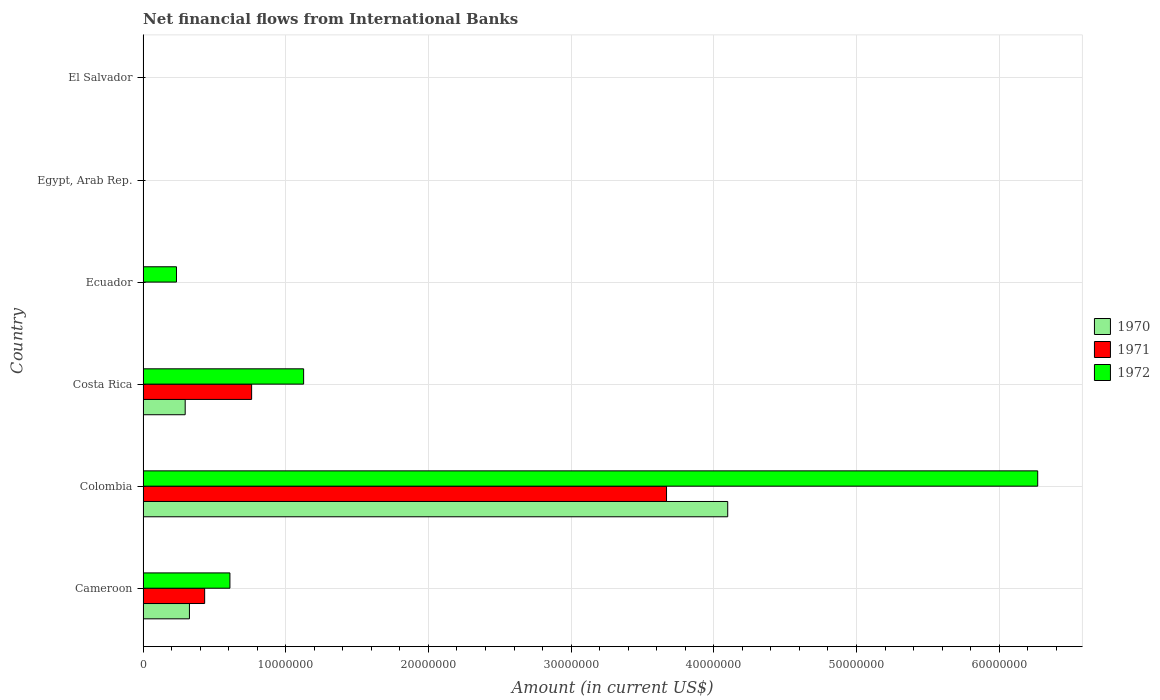Are the number of bars per tick equal to the number of legend labels?
Make the answer very short. No. Are the number of bars on each tick of the Y-axis equal?
Provide a short and direct response. No. What is the label of the 6th group of bars from the top?
Your response must be concise. Cameroon. In how many cases, is the number of bars for a given country not equal to the number of legend labels?
Your answer should be compact. 3. Across all countries, what is the maximum net financial aid flows in 1972?
Your response must be concise. 6.27e+07. Across all countries, what is the minimum net financial aid flows in 1972?
Ensure brevity in your answer.  0. In which country was the net financial aid flows in 1971 maximum?
Your response must be concise. Colombia. What is the total net financial aid flows in 1972 in the graph?
Give a very brief answer. 8.24e+07. What is the difference between the net financial aid flows in 1972 in Cameroon and that in Colombia?
Offer a very short reply. -5.66e+07. What is the difference between the net financial aid flows in 1972 in El Salvador and the net financial aid flows in 1970 in Costa Rica?
Your answer should be very brief. -2.95e+06. What is the average net financial aid flows in 1971 per country?
Offer a very short reply. 8.10e+06. What is the difference between the net financial aid flows in 1971 and net financial aid flows in 1970 in Cameroon?
Offer a very short reply. 1.07e+06. In how many countries, is the net financial aid flows in 1971 greater than 42000000 US$?
Your response must be concise. 0. What is the ratio of the net financial aid flows in 1970 in Cameroon to that in Colombia?
Give a very brief answer. 0.08. Is the difference between the net financial aid flows in 1971 in Cameroon and Colombia greater than the difference between the net financial aid flows in 1970 in Cameroon and Colombia?
Keep it short and to the point. Yes. What is the difference between the highest and the second highest net financial aid flows in 1972?
Ensure brevity in your answer.  5.14e+07. What is the difference between the highest and the lowest net financial aid flows in 1971?
Keep it short and to the point. 3.67e+07. In how many countries, is the net financial aid flows in 1971 greater than the average net financial aid flows in 1971 taken over all countries?
Your answer should be compact. 1. Is it the case that in every country, the sum of the net financial aid flows in 1972 and net financial aid flows in 1970 is greater than the net financial aid flows in 1971?
Your response must be concise. No. Are all the bars in the graph horizontal?
Offer a terse response. Yes. What is the difference between two consecutive major ticks on the X-axis?
Offer a terse response. 1.00e+07. Are the values on the major ticks of X-axis written in scientific E-notation?
Provide a short and direct response. No. Does the graph contain any zero values?
Give a very brief answer. Yes. Where does the legend appear in the graph?
Give a very brief answer. Center right. What is the title of the graph?
Offer a very short reply. Net financial flows from International Banks. What is the label or title of the Y-axis?
Ensure brevity in your answer.  Country. What is the Amount (in current US$) of 1970 in Cameroon?
Your response must be concise. 3.25e+06. What is the Amount (in current US$) of 1971 in Cameroon?
Keep it short and to the point. 4.32e+06. What is the Amount (in current US$) in 1972 in Cameroon?
Your answer should be compact. 6.09e+06. What is the Amount (in current US$) in 1970 in Colombia?
Keep it short and to the point. 4.10e+07. What is the Amount (in current US$) in 1971 in Colombia?
Offer a terse response. 3.67e+07. What is the Amount (in current US$) in 1972 in Colombia?
Provide a short and direct response. 6.27e+07. What is the Amount (in current US$) in 1970 in Costa Rica?
Make the answer very short. 2.95e+06. What is the Amount (in current US$) of 1971 in Costa Rica?
Make the answer very short. 7.61e+06. What is the Amount (in current US$) in 1972 in Costa Rica?
Offer a terse response. 1.13e+07. What is the Amount (in current US$) in 1970 in Ecuador?
Give a very brief answer. 0. What is the Amount (in current US$) of 1971 in Ecuador?
Give a very brief answer. 0. What is the Amount (in current US$) of 1972 in Ecuador?
Provide a short and direct response. 2.34e+06. What is the Amount (in current US$) in 1970 in Egypt, Arab Rep.?
Your response must be concise. 0. What is the Amount (in current US$) in 1971 in Egypt, Arab Rep.?
Your answer should be very brief. 0. What is the Amount (in current US$) of 1970 in El Salvador?
Provide a succinct answer. 0. What is the Amount (in current US$) of 1971 in El Salvador?
Offer a terse response. 0. What is the Amount (in current US$) of 1972 in El Salvador?
Provide a succinct answer. 0. Across all countries, what is the maximum Amount (in current US$) of 1970?
Provide a succinct answer. 4.10e+07. Across all countries, what is the maximum Amount (in current US$) in 1971?
Offer a terse response. 3.67e+07. Across all countries, what is the maximum Amount (in current US$) of 1972?
Your answer should be very brief. 6.27e+07. Across all countries, what is the minimum Amount (in current US$) in 1970?
Provide a succinct answer. 0. Across all countries, what is the minimum Amount (in current US$) of 1971?
Give a very brief answer. 0. Across all countries, what is the minimum Amount (in current US$) in 1972?
Your response must be concise. 0. What is the total Amount (in current US$) in 1970 in the graph?
Make the answer very short. 4.72e+07. What is the total Amount (in current US$) in 1971 in the graph?
Give a very brief answer. 4.86e+07. What is the total Amount (in current US$) in 1972 in the graph?
Make the answer very short. 8.24e+07. What is the difference between the Amount (in current US$) of 1970 in Cameroon and that in Colombia?
Your answer should be compact. -3.77e+07. What is the difference between the Amount (in current US$) in 1971 in Cameroon and that in Colombia?
Offer a terse response. -3.24e+07. What is the difference between the Amount (in current US$) of 1972 in Cameroon and that in Colombia?
Offer a terse response. -5.66e+07. What is the difference between the Amount (in current US$) of 1970 in Cameroon and that in Costa Rica?
Make the answer very short. 2.98e+05. What is the difference between the Amount (in current US$) of 1971 in Cameroon and that in Costa Rica?
Offer a very short reply. -3.29e+06. What is the difference between the Amount (in current US$) of 1972 in Cameroon and that in Costa Rica?
Provide a short and direct response. -5.17e+06. What is the difference between the Amount (in current US$) in 1972 in Cameroon and that in Ecuador?
Provide a succinct answer. 3.74e+06. What is the difference between the Amount (in current US$) in 1970 in Colombia and that in Costa Rica?
Keep it short and to the point. 3.80e+07. What is the difference between the Amount (in current US$) of 1971 in Colombia and that in Costa Rica?
Offer a terse response. 2.91e+07. What is the difference between the Amount (in current US$) in 1972 in Colombia and that in Costa Rica?
Your answer should be very brief. 5.14e+07. What is the difference between the Amount (in current US$) in 1972 in Colombia and that in Ecuador?
Your response must be concise. 6.04e+07. What is the difference between the Amount (in current US$) in 1972 in Costa Rica and that in Ecuador?
Your answer should be very brief. 8.91e+06. What is the difference between the Amount (in current US$) in 1970 in Cameroon and the Amount (in current US$) in 1971 in Colombia?
Your answer should be very brief. -3.34e+07. What is the difference between the Amount (in current US$) in 1970 in Cameroon and the Amount (in current US$) in 1972 in Colombia?
Your response must be concise. -5.94e+07. What is the difference between the Amount (in current US$) in 1971 in Cameroon and the Amount (in current US$) in 1972 in Colombia?
Ensure brevity in your answer.  -5.84e+07. What is the difference between the Amount (in current US$) of 1970 in Cameroon and the Amount (in current US$) of 1971 in Costa Rica?
Your answer should be very brief. -4.36e+06. What is the difference between the Amount (in current US$) in 1970 in Cameroon and the Amount (in current US$) in 1972 in Costa Rica?
Ensure brevity in your answer.  -8.00e+06. What is the difference between the Amount (in current US$) in 1971 in Cameroon and the Amount (in current US$) in 1972 in Costa Rica?
Give a very brief answer. -6.94e+06. What is the difference between the Amount (in current US$) of 1970 in Cameroon and the Amount (in current US$) of 1972 in Ecuador?
Provide a succinct answer. 9.08e+05. What is the difference between the Amount (in current US$) of 1971 in Cameroon and the Amount (in current US$) of 1972 in Ecuador?
Your answer should be very brief. 1.98e+06. What is the difference between the Amount (in current US$) in 1970 in Colombia and the Amount (in current US$) in 1971 in Costa Rica?
Offer a terse response. 3.34e+07. What is the difference between the Amount (in current US$) of 1970 in Colombia and the Amount (in current US$) of 1972 in Costa Rica?
Your answer should be very brief. 2.97e+07. What is the difference between the Amount (in current US$) in 1971 in Colombia and the Amount (in current US$) in 1972 in Costa Rica?
Make the answer very short. 2.54e+07. What is the difference between the Amount (in current US$) in 1970 in Colombia and the Amount (in current US$) in 1972 in Ecuador?
Your response must be concise. 3.86e+07. What is the difference between the Amount (in current US$) of 1971 in Colombia and the Amount (in current US$) of 1972 in Ecuador?
Your response must be concise. 3.43e+07. What is the difference between the Amount (in current US$) in 1970 in Costa Rica and the Amount (in current US$) in 1972 in Ecuador?
Your answer should be very brief. 6.10e+05. What is the difference between the Amount (in current US$) of 1971 in Costa Rica and the Amount (in current US$) of 1972 in Ecuador?
Ensure brevity in your answer.  5.27e+06. What is the average Amount (in current US$) in 1970 per country?
Your answer should be very brief. 7.86e+06. What is the average Amount (in current US$) of 1971 per country?
Provide a short and direct response. 8.10e+06. What is the average Amount (in current US$) of 1972 per country?
Your response must be concise. 1.37e+07. What is the difference between the Amount (in current US$) of 1970 and Amount (in current US$) of 1971 in Cameroon?
Your response must be concise. -1.07e+06. What is the difference between the Amount (in current US$) of 1970 and Amount (in current US$) of 1972 in Cameroon?
Your answer should be compact. -2.84e+06. What is the difference between the Amount (in current US$) in 1971 and Amount (in current US$) in 1972 in Cameroon?
Ensure brevity in your answer.  -1.77e+06. What is the difference between the Amount (in current US$) in 1970 and Amount (in current US$) in 1971 in Colombia?
Give a very brief answer. 4.29e+06. What is the difference between the Amount (in current US$) in 1970 and Amount (in current US$) in 1972 in Colombia?
Your answer should be compact. -2.17e+07. What is the difference between the Amount (in current US$) of 1971 and Amount (in current US$) of 1972 in Colombia?
Provide a succinct answer. -2.60e+07. What is the difference between the Amount (in current US$) in 1970 and Amount (in current US$) in 1971 in Costa Rica?
Offer a very short reply. -4.66e+06. What is the difference between the Amount (in current US$) in 1970 and Amount (in current US$) in 1972 in Costa Rica?
Keep it short and to the point. -8.30e+06. What is the difference between the Amount (in current US$) in 1971 and Amount (in current US$) in 1972 in Costa Rica?
Offer a very short reply. -3.64e+06. What is the ratio of the Amount (in current US$) of 1970 in Cameroon to that in Colombia?
Give a very brief answer. 0.08. What is the ratio of the Amount (in current US$) of 1971 in Cameroon to that in Colombia?
Your answer should be very brief. 0.12. What is the ratio of the Amount (in current US$) in 1972 in Cameroon to that in Colombia?
Offer a terse response. 0.1. What is the ratio of the Amount (in current US$) in 1970 in Cameroon to that in Costa Rica?
Keep it short and to the point. 1.1. What is the ratio of the Amount (in current US$) of 1971 in Cameroon to that in Costa Rica?
Your response must be concise. 0.57. What is the ratio of the Amount (in current US$) in 1972 in Cameroon to that in Costa Rica?
Your answer should be compact. 0.54. What is the ratio of the Amount (in current US$) in 1972 in Cameroon to that in Ecuador?
Keep it short and to the point. 2.6. What is the ratio of the Amount (in current US$) of 1970 in Colombia to that in Costa Rica?
Your response must be concise. 13.88. What is the ratio of the Amount (in current US$) in 1971 in Colombia to that in Costa Rica?
Your response must be concise. 4.82. What is the ratio of the Amount (in current US$) in 1972 in Colombia to that in Costa Rica?
Provide a succinct answer. 5.57. What is the ratio of the Amount (in current US$) in 1972 in Colombia to that in Ecuador?
Your response must be concise. 26.77. What is the ratio of the Amount (in current US$) of 1972 in Costa Rica to that in Ecuador?
Ensure brevity in your answer.  4.8. What is the difference between the highest and the second highest Amount (in current US$) in 1970?
Your response must be concise. 3.77e+07. What is the difference between the highest and the second highest Amount (in current US$) of 1971?
Keep it short and to the point. 2.91e+07. What is the difference between the highest and the second highest Amount (in current US$) in 1972?
Your response must be concise. 5.14e+07. What is the difference between the highest and the lowest Amount (in current US$) of 1970?
Offer a very short reply. 4.10e+07. What is the difference between the highest and the lowest Amount (in current US$) in 1971?
Give a very brief answer. 3.67e+07. What is the difference between the highest and the lowest Amount (in current US$) in 1972?
Provide a short and direct response. 6.27e+07. 